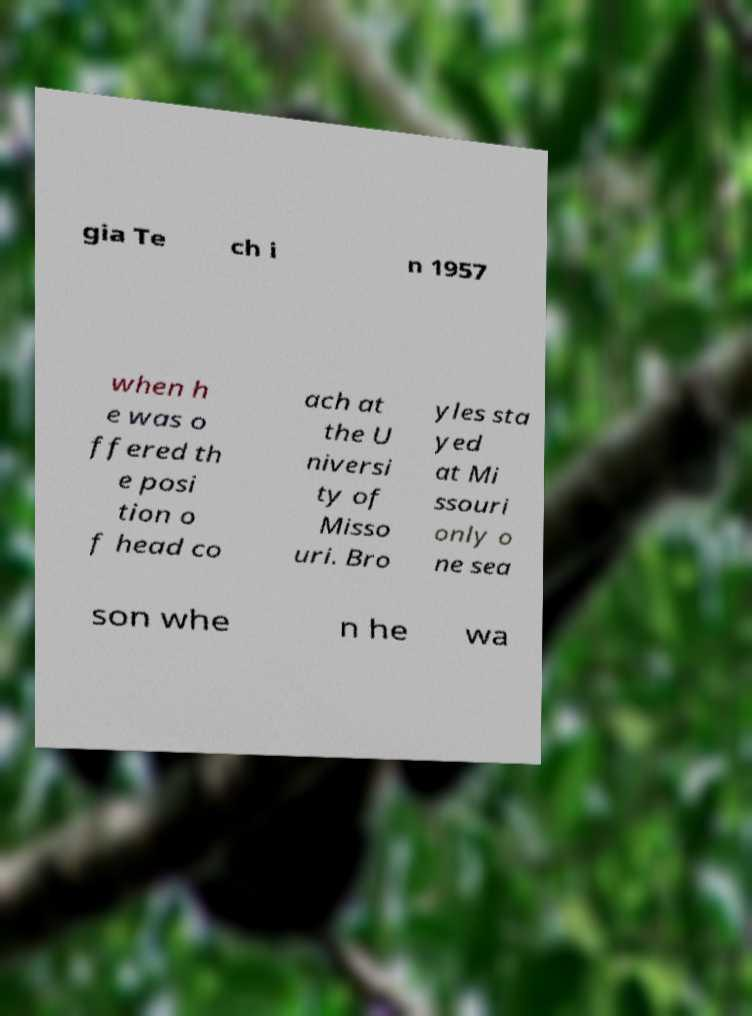What messages or text are displayed in this image? I need them in a readable, typed format. gia Te ch i n 1957 when h e was o ffered th e posi tion o f head co ach at the U niversi ty of Misso uri. Bro yles sta yed at Mi ssouri only o ne sea son whe n he wa 